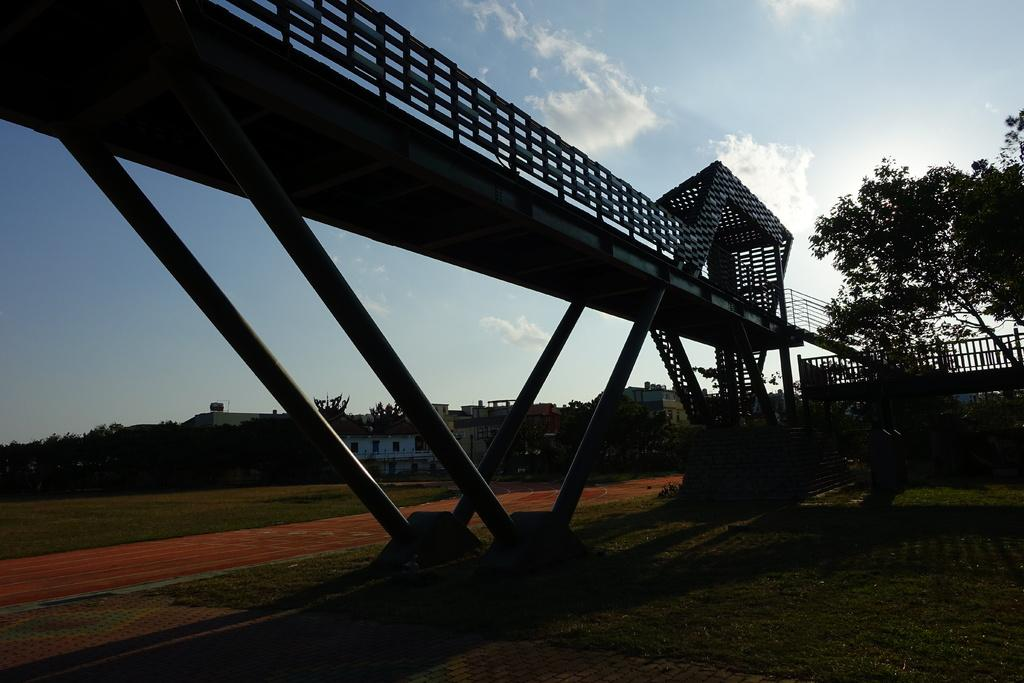What structure is present in the image? There is a bridge in the image. What can be seen on the right side of the image? There is a tree on the right side of the image. What is visible in the background of the image? There are buildings, trees, and the sky visible in the background of the image. What type of bed is visible in the image? There is no bed present in the image; it features a bridge, a tree, and various background elements. 